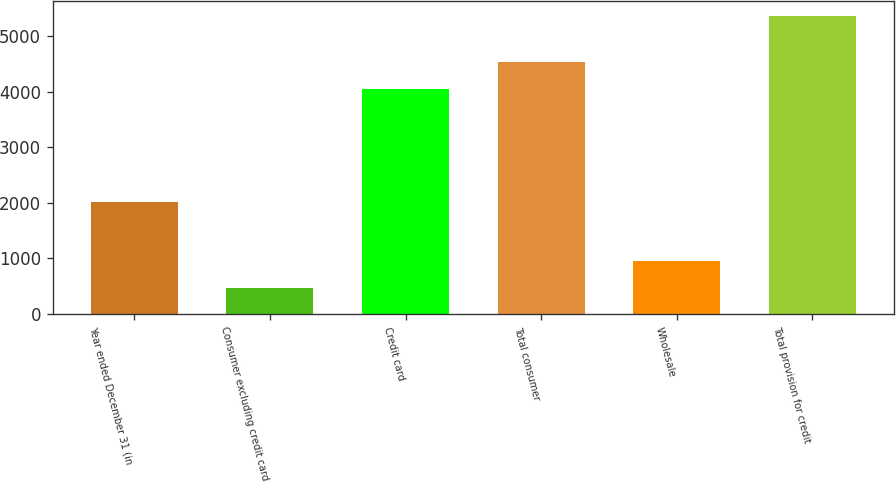Convert chart to OTSL. <chart><loc_0><loc_0><loc_500><loc_500><bar_chart><fcel>Year ended December 31 (in<fcel>Consumer excluding credit card<fcel>Credit card<fcel>Total consumer<fcel>Wholesale<fcel>Total provision for credit<nl><fcel>2016<fcel>467<fcel>4042<fcel>4531.4<fcel>956.4<fcel>5361<nl></chart> 